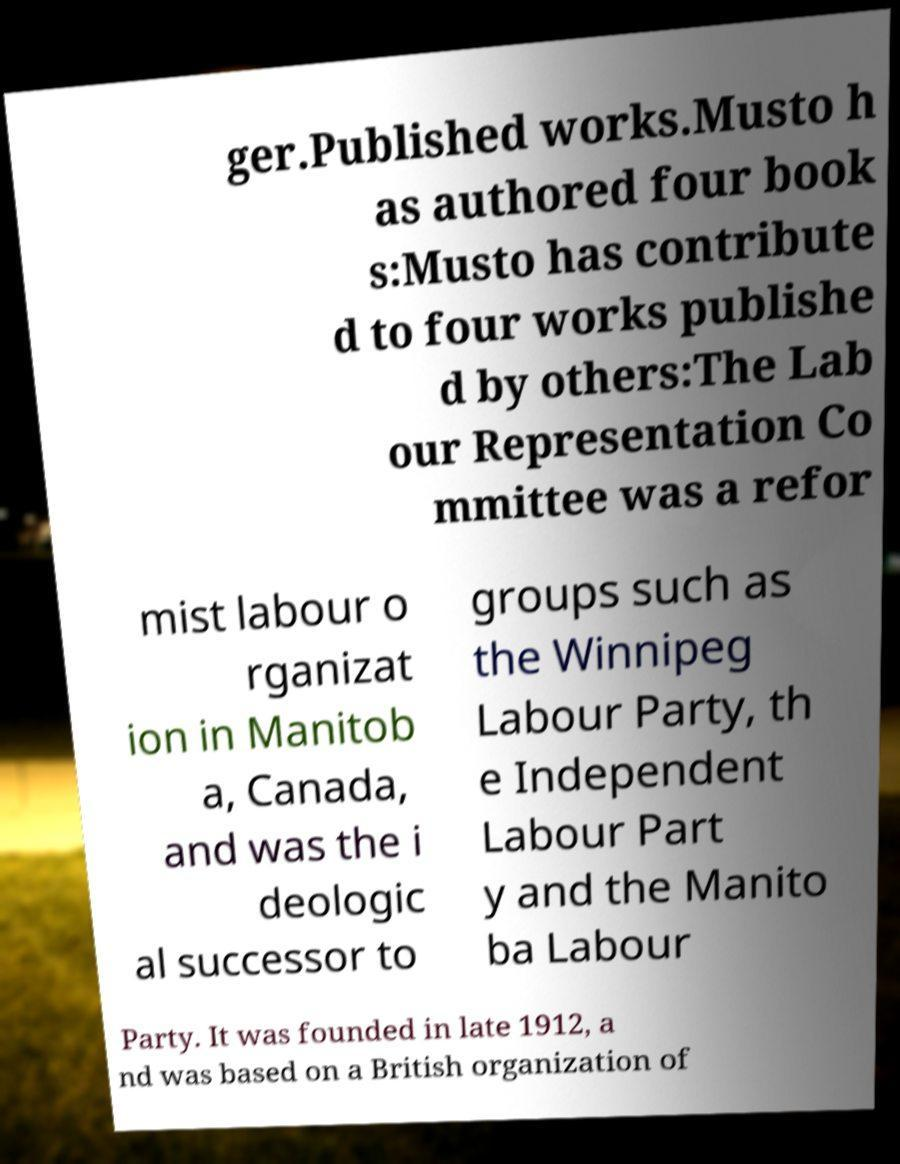Could you extract and type out the text from this image? ger.Published works.Musto h as authored four book s:Musto has contribute d to four works publishe d by others:The Lab our Representation Co mmittee was a refor mist labour o rganizat ion in Manitob a, Canada, and was the i deologic al successor to groups such as the Winnipeg Labour Party, th e Independent Labour Part y and the Manito ba Labour Party. It was founded in late 1912, a nd was based on a British organization of 